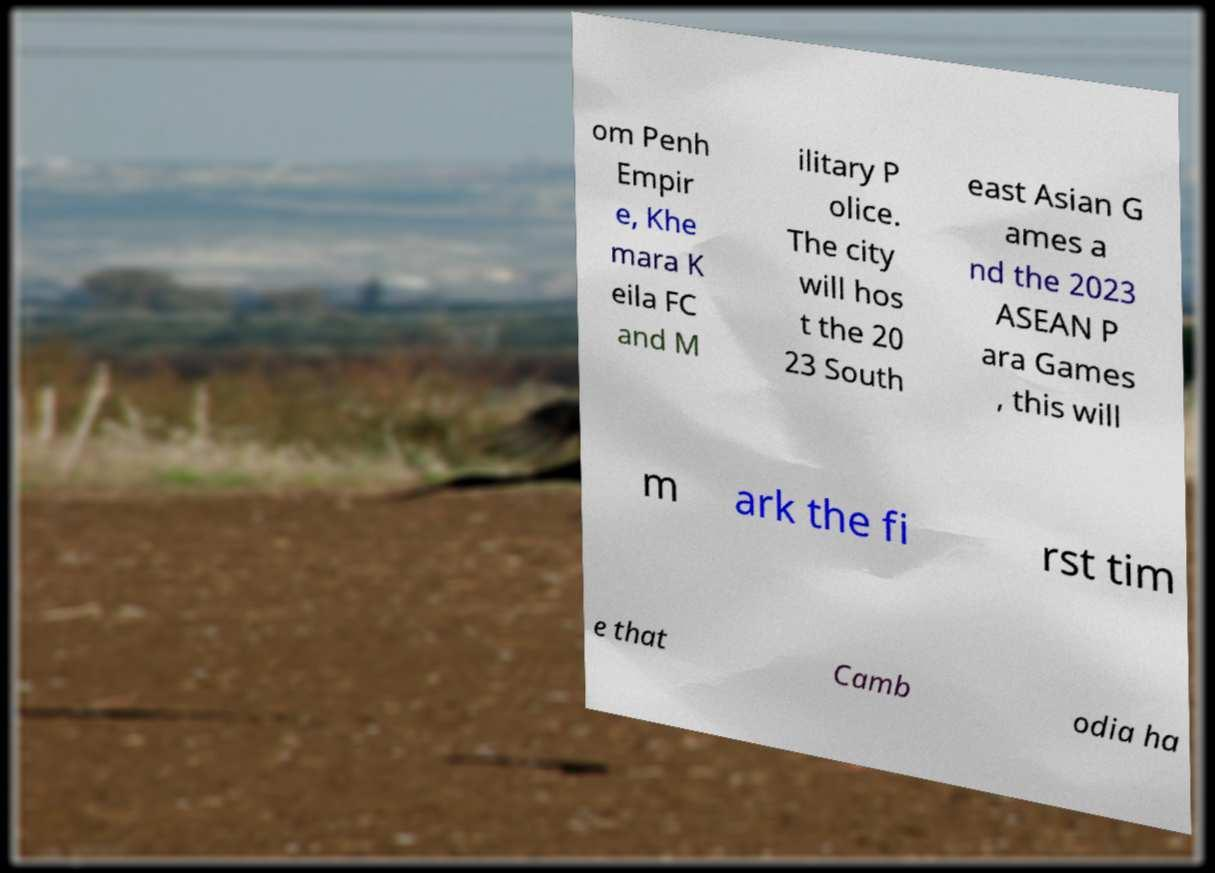Could you assist in decoding the text presented in this image and type it out clearly? om Penh Empir e, Khe mara K eila FC and M ilitary P olice. The city will hos t the 20 23 South east Asian G ames a nd the 2023 ASEAN P ara Games , this will m ark the fi rst tim e that Camb odia ha 